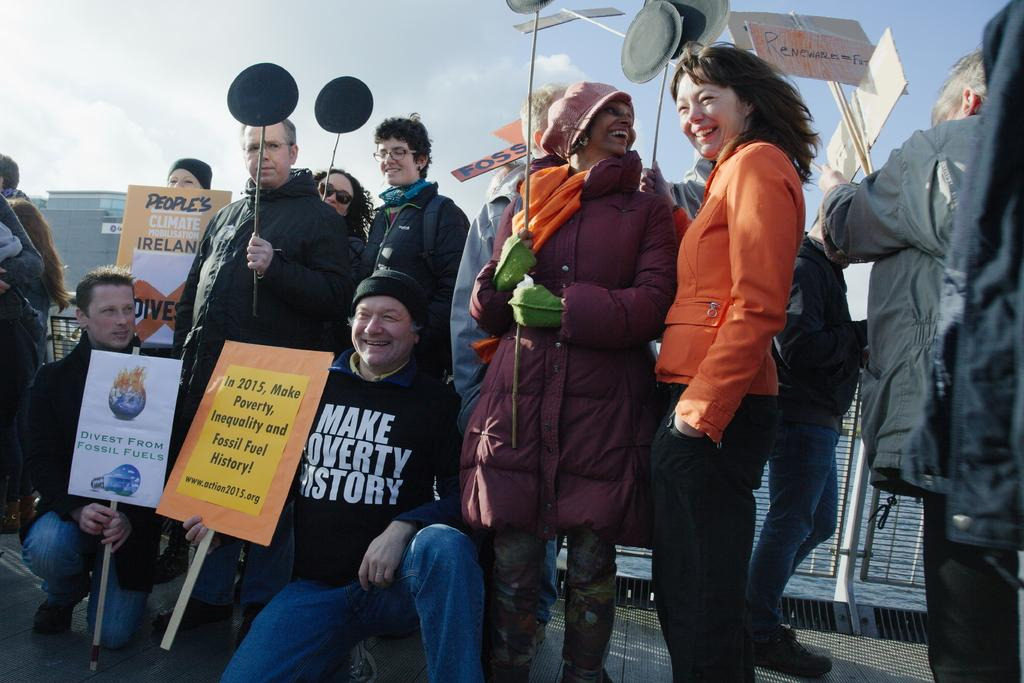What are the people in the image holding? The people in the image are holding placards. What is located near the people in the image? There is a metal fence in the image. What can be seen in the background of the image? There is water, buildings, and the sky visible in the background of the image. What type of joke is being told by the beam in the image? There is no beam present in the image, and therefore no joke can be told by a beam. 